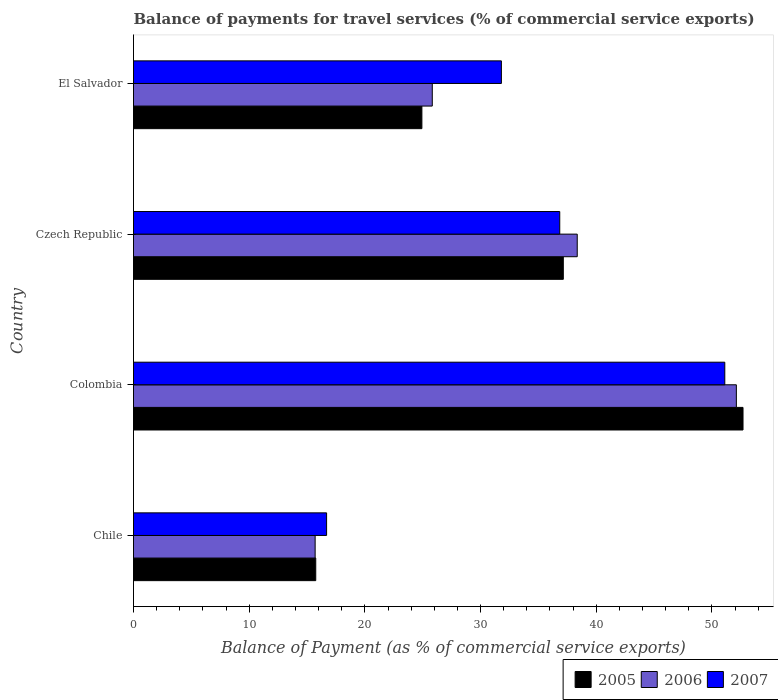How many groups of bars are there?
Give a very brief answer. 4. How many bars are there on the 2nd tick from the bottom?
Offer a terse response. 3. What is the label of the 1st group of bars from the top?
Provide a short and direct response. El Salvador. In how many cases, is the number of bars for a given country not equal to the number of legend labels?
Your answer should be compact. 0. What is the balance of payments for travel services in 2007 in El Salvador?
Keep it short and to the point. 31.8. Across all countries, what is the maximum balance of payments for travel services in 2007?
Provide a short and direct response. 51.11. Across all countries, what is the minimum balance of payments for travel services in 2007?
Ensure brevity in your answer.  16.69. In which country was the balance of payments for travel services in 2007 minimum?
Your answer should be very brief. Chile. What is the total balance of payments for travel services in 2005 in the graph?
Provide a succinct answer. 130.52. What is the difference between the balance of payments for travel services in 2005 in Czech Republic and that in El Salvador?
Offer a very short reply. 12.22. What is the difference between the balance of payments for travel services in 2006 in El Salvador and the balance of payments for travel services in 2005 in Chile?
Make the answer very short. 10.07. What is the average balance of payments for travel services in 2005 per country?
Make the answer very short. 32.63. What is the difference between the balance of payments for travel services in 2006 and balance of payments for travel services in 2007 in Colombia?
Your answer should be compact. 1. In how many countries, is the balance of payments for travel services in 2007 greater than 46 %?
Give a very brief answer. 1. What is the ratio of the balance of payments for travel services in 2006 in Colombia to that in Czech Republic?
Ensure brevity in your answer.  1.36. Is the balance of payments for travel services in 2005 in Chile less than that in Colombia?
Keep it short and to the point. Yes. What is the difference between the highest and the second highest balance of payments for travel services in 2007?
Your response must be concise. 14.27. What is the difference between the highest and the lowest balance of payments for travel services in 2005?
Your answer should be compact. 36.93. Is the sum of the balance of payments for travel services in 2006 in Chile and Czech Republic greater than the maximum balance of payments for travel services in 2007 across all countries?
Your response must be concise. Yes. What does the 1st bar from the top in Colombia represents?
Keep it short and to the point. 2007. What does the 2nd bar from the bottom in El Salvador represents?
Give a very brief answer. 2006. What is the difference between two consecutive major ticks on the X-axis?
Offer a very short reply. 10. Does the graph contain any zero values?
Offer a terse response. No. Does the graph contain grids?
Your answer should be compact. No. What is the title of the graph?
Make the answer very short. Balance of payments for travel services (% of commercial service exports). What is the label or title of the X-axis?
Offer a terse response. Balance of Payment (as % of commercial service exports). What is the label or title of the Y-axis?
Make the answer very short. Country. What is the Balance of Payment (as % of commercial service exports) in 2005 in Chile?
Offer a very short reply. 15.75. What is the Balance of Payment (as % of commercial service exports) of 2006 in Chile?
Provide a short and direct response. 15.7. What is the Balance of Payment (as % of commercial service exports) of 2007 in Chile?
Offer a terse response. 16.69. What is the Balance of Payment (as % of commercial service exports) in 2005 in Colombia?
Make the answer very short. 52.69. What is the Balance of Payment (as % of commercial service exports) in 2006 in Colombia?
Give a very brief answer. 52.11. What is the Balance of Payment (as % of commercial service exports) in 2007 in Colombia?
Ensure brevity in your answer.  51.11. What is the Balance of Payment (as % of commercial service exports) in 2005 in Czech Republic?
Your answer should be very brief. 37.15. What is the Balance of Payment (as % of commercial service exports) of 2006 in Czech Republic?
Your response must be concise. 38.36. What is the Balance of Payment (as % of commercial service exports) of 2007 in Czech Republic?
Give a very brief answer. 36.84. What is the Balance of Payment (as % of commercial service exports) in 2005 in El Salvador?
Make the answer very short. 24.93. What is the Balance of Payment (as % of commercial service exports) of 2006 in El Salvador?
Keep it short and to the point. 25.83. What is the Balance of Payment (as % of commercial service exports) of 2007 in El Salvador?
Offer a terse response. 31.8. Across all countries, what is the maximum Balance of Payment (as % of commercial service exports) of 2005?
Provide a succinct answer. 52.69. Across all countries, what is the maximum Balance of Payment (as % of commercial service exports) of 2006?
Keep it short and to the point. 52.11. Across all countries, what is the maximum Balance of Payment (as % of commercial service exports) of 2007?
Keep it short and to the point. 51.11. Across all countries, what is the minimum Balance of Payment (as % of commercial service exports) of 2005?
Keep it short and to the point. 15.75. Across all countries, what is the minimum Balance of Payment (as % of commercial service exports) of 2006?
Give a very brief answer. 15.7. Across all countries, what is the minimum Balance of Payment (as % of commercial service exports) in 2007?
Your response must be concise. 16.69. What is the total Balance of Payment (as % of commercial service exports) in 2005 in the graph?
Your answer should be very brief. 130.52. What is the total Balance of Payment (as % of commercial service exports) in 2006 in the graph?
Give a very brief answer. 131.99. What is the total Balance of Payment (as % of commercial service exports) in 2007 in the graph?
Give a very brief answer. 136.44. What is the difference between the Balance of Payment (as % of commercial service exports) in 2005 in Chile and that in Colombia?
Offer a terse response. -36.93. What is the difference between the Balance of Payment (as % of commercial service exports) in 2006 in Chile and that in Colombia?
Provide a short and direct response. -36.41. What is the difference between the Balance of Payment (as % of commercial service exports) in 2007 in Chile and that in Colombia?
Provide a short and direct response. -34.42. What is the difference between the Balance of Payment (as % of commercial service exports) in 2005 in Chile and that in Czech Republic?
Provide a short and direct response. -21.4. What is the difference between the Balance of Payment (as % of commercial service exports) in 2006 in Chile and that in Czech Republic?
Ensure brevity in your answer.  -22.66. What is the difference between the Balance of Payment (as % of commercial service exports) of 2007 in Chile and that in Czech Republic?
Your response must be concise. -20.15. What is the difference between the Balance of Payment (as % of commercial service exports) of 2005 in Chile and that in El Salvador?
Offer a terse response. -9.18. What is the difference between the Balance of Payment (as % of commercial service exports) of 2006 in Chile and that in El Salvador?
Keep it short and to the point. -10.13. What is the difference between the Balance of Payment (as % of commercial service exports) of 2007 in Chile and that in El Salvador?
Your answer should be very brief. -15.11. What is the difference between the Balance of Payment (as % of commercial service exports) in 2005 in Colombia and that in Czech Republic?
Keep it short and to the point. 15.53. What is the difference between the Balance of Payment (as % of commercial service exports) of 2006 in Colombia and that in Czech Republic?
Your answer should be very brief. 13.76. What is the difference between the Balance of Payment (as % of commercial service exports) of 2007 in Colombia and that in Czech Republic?
Offer a very short reply. 14.27. What is the difference between the Balance of Payment (as % of commercial service exports) of 2005 in Colombia and that in El Salvador?
Give a very brief answer. 27.76. What is the difference between the Balance of Payment (as % of commercial service exports) in 2006 in Colombia and that in El Salvador?
Offer a terse response. 26.28. What is the difference between the Balance of Payment (as % of commercial service exports) in 2007 in Colombia and that in El Salvador?
Ensure brevity in your answer.  19.31. What is the difference between the Balance of Payment (as % of commercial service exports) of 2005 in Czech Republic and that in El Salvador?
Your answer should be very brief. 12.22. What is the difference between the Balance of Payment (as % of commercial service exports) in 2006 in Czech Republic and that in El Salvador?
Your answer should be very brief. 12.53. What is the difference between the Balance of Payment (as % of commercial service exports) in 2007 in Czech Republic and that in El Salvador?
Provide a short and direct response. 5.04. What is the difference between the Balance of Payment (as % of commercial service exports) in 2005 in Chile and the Balance of Payment (as % of commercial service exports) in 2006 in Colombia?
Offer a very short reply. -36.36. What is the difference between the Balance of Payment (as % of commercial service exports) of 2005 in Chile and the Balance of Payment (as % of commercial service exports) of 2007 in Colombia?
Keep it short and to the point. -35.36. What is the difference between the Balance of Payment (as % of commercial service exports) of 2006 in Chile and the Balance of Payment (as % of commercial service exports) of 2007 in Colombia?
Your answer should be compact. -35.41. What is the difference between the Balance of Payment (as % of commercial service exports) in 2005 in Chile and the Balance of Payment (as % of commercial service exports) in 2006 in Czech Republic?
Keep it short and to the point. -22.6. What is the difference between the Balance of Payment (as % of commercial service exports) in 2005 in Chile and the Balance of Payment (as % of commercial service exports) in 2007 in Czech Republic?
Your answer should be very brief. -21.09. What is the difference between the Balance of Payment (as % of commercial service exports) in 2006 in Chile and the Balance of Payment (as % of commercial service exports) in 2007 in Czech Republic?
Your answer should be compact. -21.14. What is the difference between the Balance of Payment (as % of commercial service exports) of 2005 in Chile and the Balance of Payment (as % of commercial service exports) of 2006 in El Salvador?
Provide a short and direct response. -10.07. What is the difference between the Balance of Payment (as % of commercial service exports) in 2005 in Chile and the Balance of Payment (as % of commercial service exports) in 2007 in El Salvador?
Keep it short and to the point. -16.05. What is the difference between the Balance of Payment (as % of commercial service exports) in 2006 in Chile and the Balance of Payment (as % of commercial service exports) in 2007 in El Salvador?
Provide a succinct answer. -16.1. What is the difference between the Balance of Payment (as % of commercial service exports) of 2005 in Colombia and the Balance of Payment (as % of commercial service exports) of 2006 in Czech Republic?
Ensure brevity in your answer.  14.33. What is the difference between the Balance of Payment (as % of commercial service exports) of 2005 in Colombia and the Balance of Payment (as % of commercial service exports) of 2007 in Czech Republic?
Provide a short and direct response. 15.84. What is the difference between the Balance of Payment (as % of commercial service exports) of 2006 in Colombia and the Balance of Payment (as % of commercial service exports) of 2007 in Czech Republic?
Your response must be concise. 15.27. What is the difference between the Balance of Payment (as % of commercial service exports) of 2005 in Colombia and the Balance of Payment (as % of commercial service exports) of 2006 in El Salvador?
Ensure brevity in your answer.  26.86. What is the difference between the Balance of Payment (as % of commercial service exports) in 2005 in Colombia and the Balance of Payment (as % of commercial service exports) in 2007 in El Salvador?
Your answer should be very brief. 20.89. What is the difference between the Balance of Payment (as % of commercial service exports) in 2006 in Colombia and the Balance of Payment (as % of commercial service exports) in 2007 in El Salvador?
Offer a terse response. 20.31. What is the difference between the Balance of Payment (as % of commercial service exports) of 2005 in Czech Republic and the Balance of Payment (as % of commercial service exports) of 2006 in El Salvador?
Keep it short and to the point. 11.33. What is the difference between the Balance of Payment (as % of commercial service exports) of 2005 in Czech Republic and the Balance of Payment (as % of commercial service exports) of 2007 in El Salvador?
Offer a very short reply. 5.35. What is the difference between the Balance of Payment (as % of commercial service exports) in 2006 in Czech Republic and the Balance of Payment (as % of commercial service exports) in 2007 in El Salvador?
Offer a very short reply. 6.56. What is the average Balance of Payment (as % of commercial service exports) in 2005 per country?
Your response must be concise. 32.63. What is the average Balance of Payment (as % of commercial service exports) in 2006 per country?
Offer a very short reply. 33. What is the average Balance of Payment (as % of commercial service exports) of 2007 per country?
Offer a very short reply. 34.11. What is the difference between the Balance of Payment (as % of commercial service exports) of 2005 and Balance of Payment (as % of commercial service exports) of 2006 in Chile?
Ensure brevity in your answer.  0.05. What is the difference between the Balance of Payment (as % of commercial service exports) in 2005 and Balance of Payment (as % of commercial service exports) in 2007 in Chile?
Your answer should be very brief. -0.94. What is the difference between the Balance of Payment (as % of commercial service exports) in 2006 and Balance of Payment (as % of commercial service exports) in 2007 in Chile?
Keep it short and to the point. -0.99. What is the difference between the Balance of Payment (as % of commercial service exports) in 2005 and Balance of Payment (as % of commercial service exports) in 2006 in Colombia?
Give a very brief answer. 0.58. What is the difference between the Balance of Payment (as % of commercial service exports) of 2005 and Balance of Payment (as % of commercial service exports) of 2007 in Colombia?
Your answer should be compact. 1.58. What is the difference between the Balance of Payment (as % of commercial service exports) of 2006 and Balance of Payment (as % of commercial service exports) of 2007 in Colombia?
Keep it short and to the point. 1. What is the difference between the Balance of Payment (as % of commercial service exports) of 2005 and Balance of Payment (as % of commercial service exports) of 2006 in Czech Republic?
Offer a very short reply. -1.2. What is the difference between the Balance of Payment (as % of commercial service exports) in 2005 and Balance of Payment (as % of commercial service exports) in 2007 in Czech Republic?
Your response must be concise. 0.31. What is the difference between the Balance of Payment (as % of commercial service exports) of 2006 and Balance of Payment (as % of commercial service exports) of 2007 in Czech Republic?
Provide a short and direct response. 1.51. What is the difference between the Balance of Payment (as % of commercial service exports) in 2005 and Balance of Payment (as % of commercial service exports) in 2006 in El Salvador?
Make the answer very short. -0.9. What is the difference between the Balance of Payment (as % of commercial service exports) of 2005 and Balance of Payment (as % of commercial service exports) of 2007 in El Salvador?
Your answer should be very brief. -6.87. What is the difference between the Balance of Payment (as % of commercial service exports) of 2006 and Balance of Payment (as % of commercial service exports) of 2007 in El Salvador?
Provide a short and direct response. -5.97. What is the ratio of the Balance of Payment (as % of commercial service exports) of 2005 in Chile to that in Colombia?
Offer a very short reply. 0.3. What is the ratio of the Balance of Payment (as % of commercial service exports) of 2006 in Chile to that in Colombia?
Keep it short and to the point. 0.3. What is the ratio of the Balance of Payment (as % of commercial service exports) in 2007 in Chile to that in Colombia?
Your answer should be compact. 0.33. What is the ratio of the Balance of Payment (as % of commercial service exports) in 2005 in Chile to that in Czech Republic?
Your answer should be compact. 0.42. What is the ratio of the Balance of Payment (as % of commercial service exports) of 2006 in Chile to that in Czech Republic?
Provide a succinct answer. 0.41. What is the ratio of the Balance of Payment (as % of commercial service exports) of 2007 in Chile to that in Czech Republic?
Your response must be concise. 0.45. What is the ratio of the Balance of Payment (as % of commercial service exports) in 2005 in Chile to that in El Salvador?
Offer a very short reply. 0.63. What is the ratio of the Balance of Payment (as % of commercial service exports) of 2006 in Chile to that in El Salvador?
Give a very brief answer. 0.61. What is the ratio of the Balance of Payment (as % of commercial service exports) of 2007 in Chile to that in El Salvador?
Offer a terse response. 0.52. What is the ratio of the Balance of Payment (as % of commercial service exports) of 2005 in Colombia to that in Czech Republic?
Your answer should be very brief. 1.42. What is the ratio of the Balance of Payment (as % of commercial service exports) of 2006 in Colombia to that in Czech Republic?
Keep it short and to the point. 1.36. What is the ratio of the Balance of Payment (as % of commercial service exports) in 2007 in Colombia to that in Czech Republic?
Offer a terse response. 1.39. What is the ratio of the Balance of Payment (as % of commercial service exports) of 2005 in Colombia to that in El Salvador?
Offer a terse response. 2.11. What is the ratio of the Balance of Payment (as % of commercial service exports) in 2006 in Colombia to that in El Salvador?
Your answer should be very brief. 2.02. What is the ratio of the Balance of Payment (as % of commercial service exports) in 2007 in Colombia to that in El Salvador?
Give a very brief answer. 1.61. What is the ratio of the Balance of Payment (as % of commercial service exports) of 2005 in Czech Republic to that in El Salvador?
Provide a short and direct response. 1.49. What is the ratio of the Balance of Payment (as % of commercial service exports) of 2006 in Czech Republic to that in El Salvador?
Provide a short and direct response. 1.49. What is the ratio of the Balance of Payment (as % of commercial service exports) in 2007 in Czech Republic to that in El Salvador?
Provide a short and direct response. 1.16. What is the difference between the highest and the second highest Balance of Payment (as % of commercial service exports) in 2005?
Make the answer very short. 15.53. What is the difference between the highest and the second highest Balance of Payment (as % of commercial service exports) in 2006?
Provide a succinct answer. 13.76. What is the difference between the highest and the second highest Balance of Payment (as % of commercial service exports) of 2007?
Offer a terse response. 14.27. What is the difference between the highest and the lowest Balance of Payment (as % of commercial service exports) of 2005?
Provide a short and direct response. 36.93. What is the difference between the highest and the lowest Balance of Payment (as % of commercial service exports) of 2006?
Provide a succinct answer. 36.41. What is the difference between the highest and the lowest Balance of Payment (as % of commercial service exports) in 2007?
Ensure brevity in your answer.  34.42. 